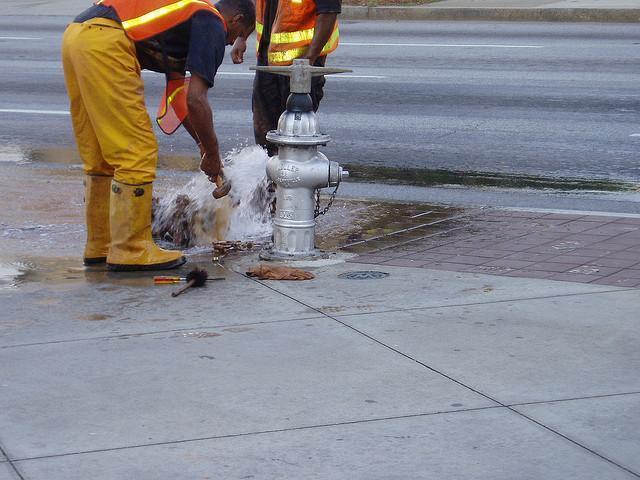How many people in the picture?
Give a very brief answer. 2. How many fire hydrants are there?
Give a very brief answer. 1. How many people are there?
Give a very brief answer. 2. How many sandwiches are on the plate?
Give a very brief answer. 0. 